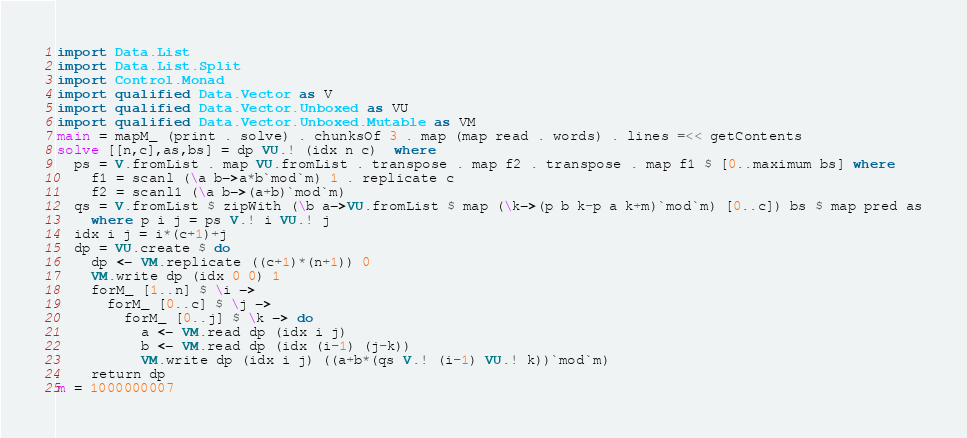Convert code to text. <code><loc_0><loc_0><loc_500><loc_500><_Haskell_>import Data.List
import Data.List.Split
import Control.Monad
import qualified Data.Vector as V
import qualified Data.Vector.Unboxed as VU
import qualified Data.Vector.Unboxed.Mutable as VM
main = mapM_ (print . solve) . chunksOf 3 . map (map read . words) . lines =<< getContents
solve [[n,c],as,bs] = dp VU.! (idx n c)  where
  ps = V.fromList . map VU.fromList . transpose . map f2 . transpose . map f1 $ [0..maximum bs] where
    f1 = scanl (\a b->a*b`mod`m) 1 . replicate c
    f2 = scanl1 (\a b->(a+b)`mod`m)
  qs = V.fromList $ zipWith (\b a->VU.fromList $ map (\k->(p b k-p a k+m)`mod`m) [0..c]) bs $ map pred as
    where p i j = ps V.! i VU.! j
  idx i j = i*(c+1)+j
  dp = VU.create $ do
    dp <- VM.replicate ((c+1)*(n+1)) 0
    VM.write dp (idx 0 0) 1
    forM_ [1..n] $ \i ->
      forM_ [0..c] $ \j ->
        forM_ [0..j] $ \k -> do
          a <- VM.read dp (idx i j)
          b <- VM.read dp (idx (i-1) (j-k))
          VM.write dp (idx i j) ((a+b*(qs V.! (i-1) VU.! k))`mod`m)
    return dp
m = 1000000007</code> 